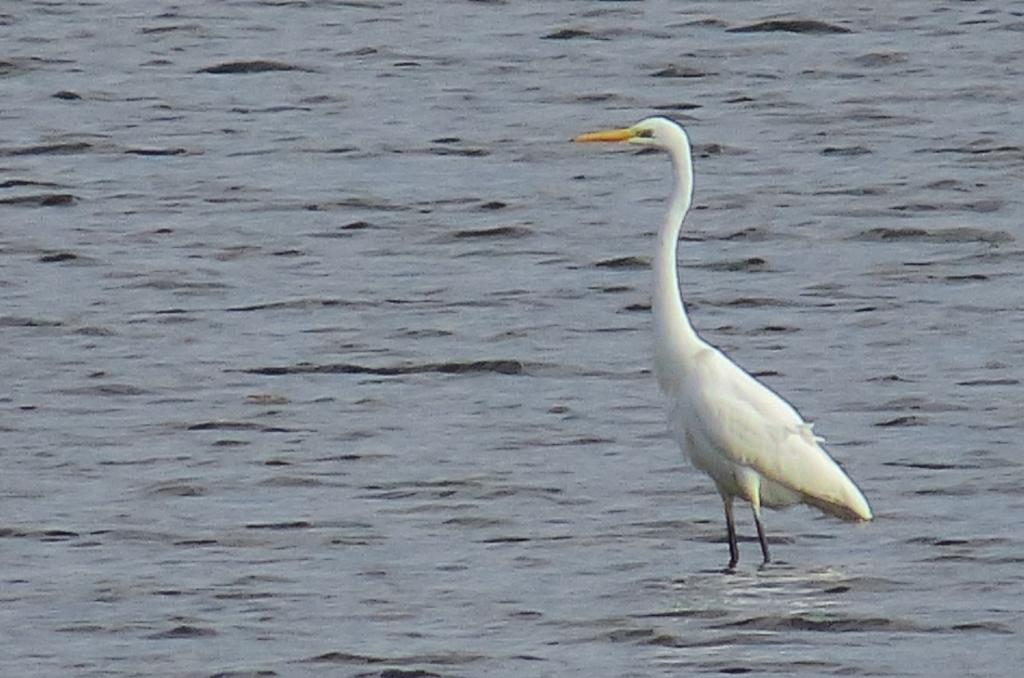What type of bird is in the image? There is a Great egret bird in the image. Where is the bird located in the image? The bird is in the water. How many ladybugs can be seen on the bird in the image? There are no ladybugs present on the bird in the image. What type of berry is being held by the bird in the image? There is no berry present in the image, and the bird is not holding anything. 